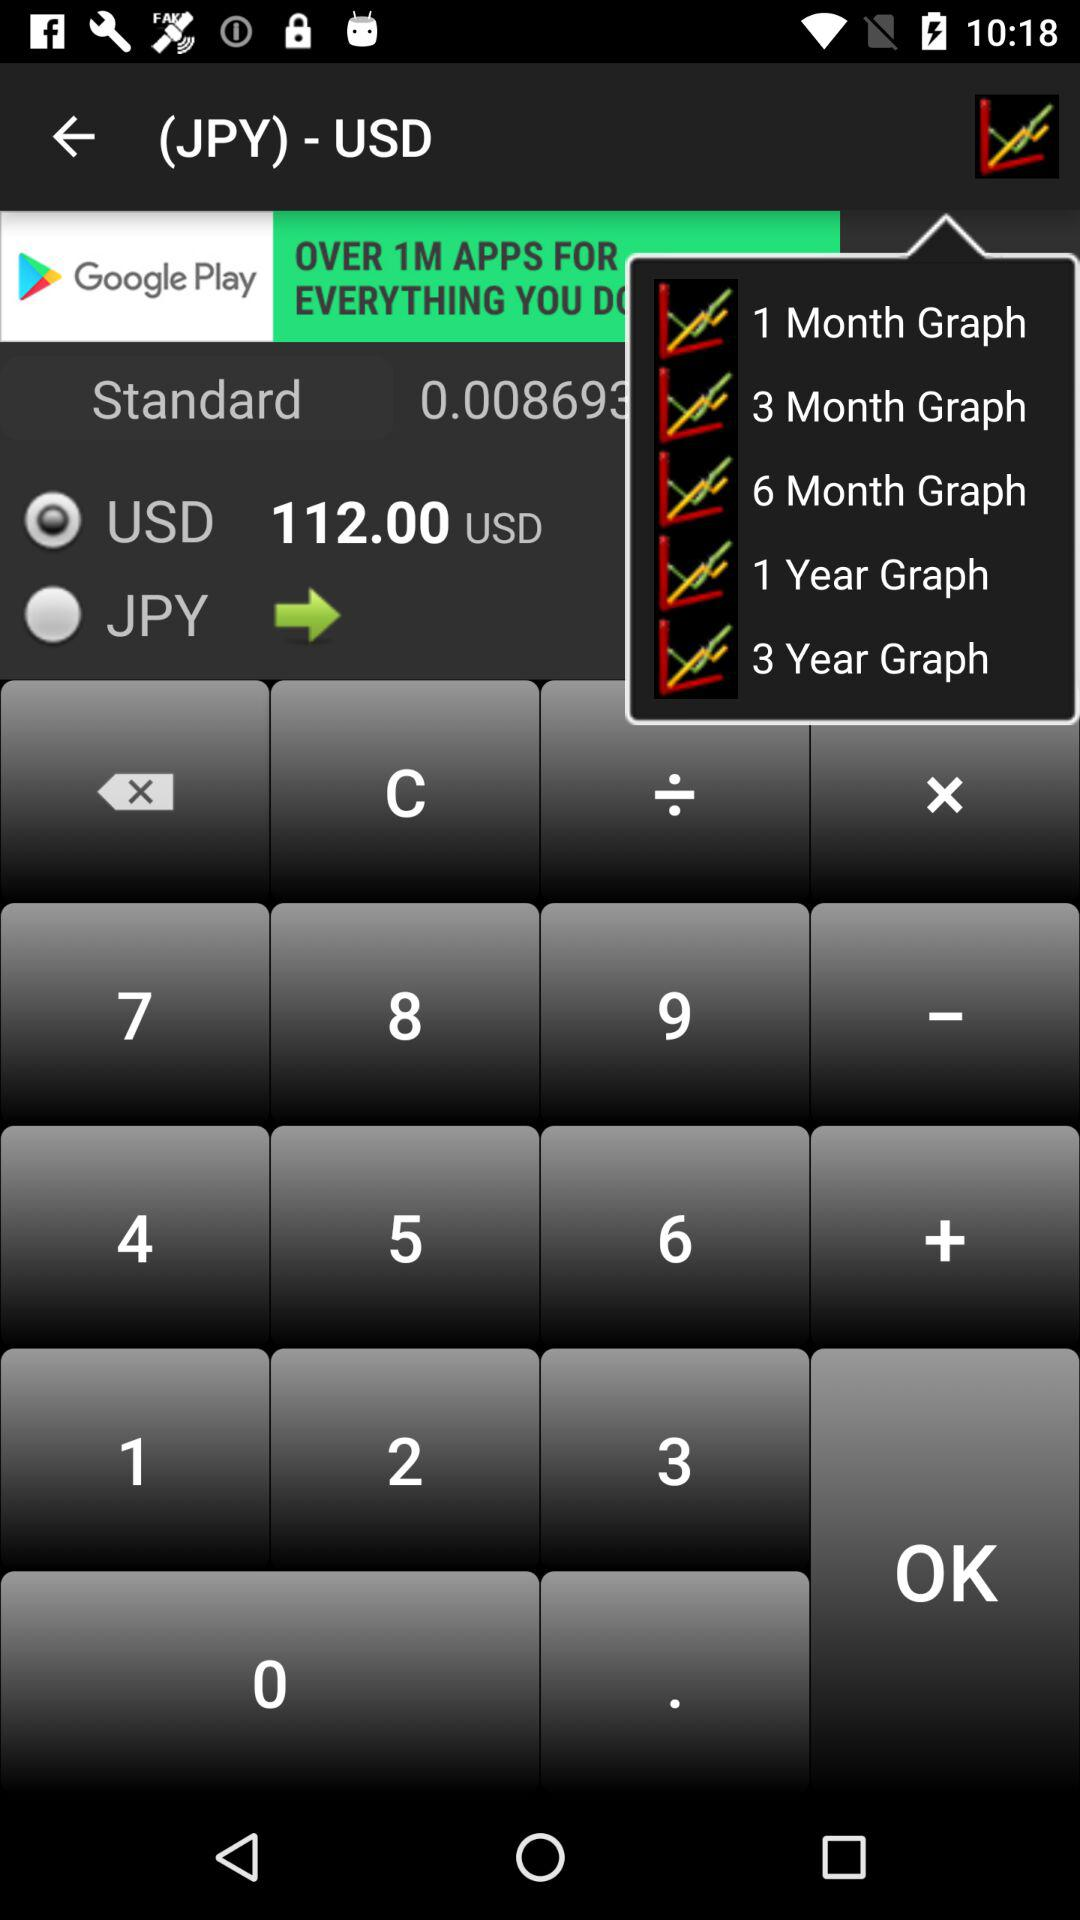What is the exchange rate between JPY and USD?
Answer the question using a single word or phrase. 0.008693 